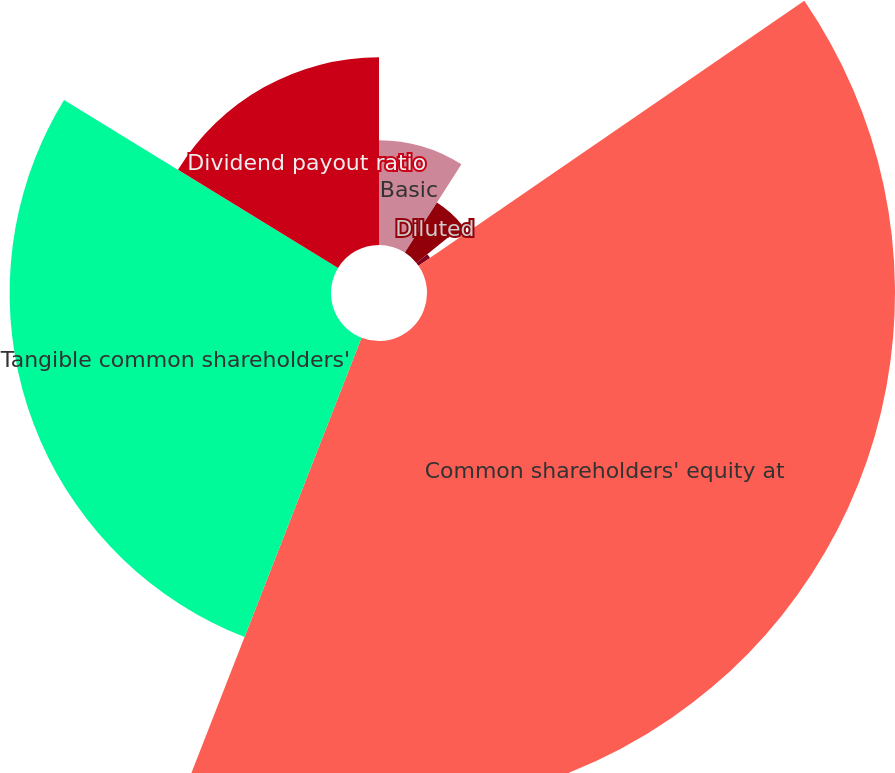<chart> <loc_0><loc_0><loc_500><loc_500><pie_chart><fcel>Basic<fcel>Diluted<fcel>Cash dividends declared<fcel>Common shareholders' equity at<fcel>Tangible common shareholders'<fcel>Dividend payout ratio<nl><fcel>9.07%<fcel>5.14%<fcel>1.21%<fcel>40.51%<fcel>27.82%<fcel>16.25%<nl></chart> 